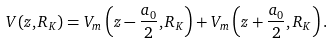<formula> <loc_0><loc_0><loc_500><loc_500>V ( z , R _ { K } ) = V _ { m } \left ( z - \frac { a _ { 0 } } { 2 } , R _ { K } \right ) + V _ { m } \left ( z + \frac { a _ { 0 } } { 2 } , R _ { K } \right ) .</formula> 